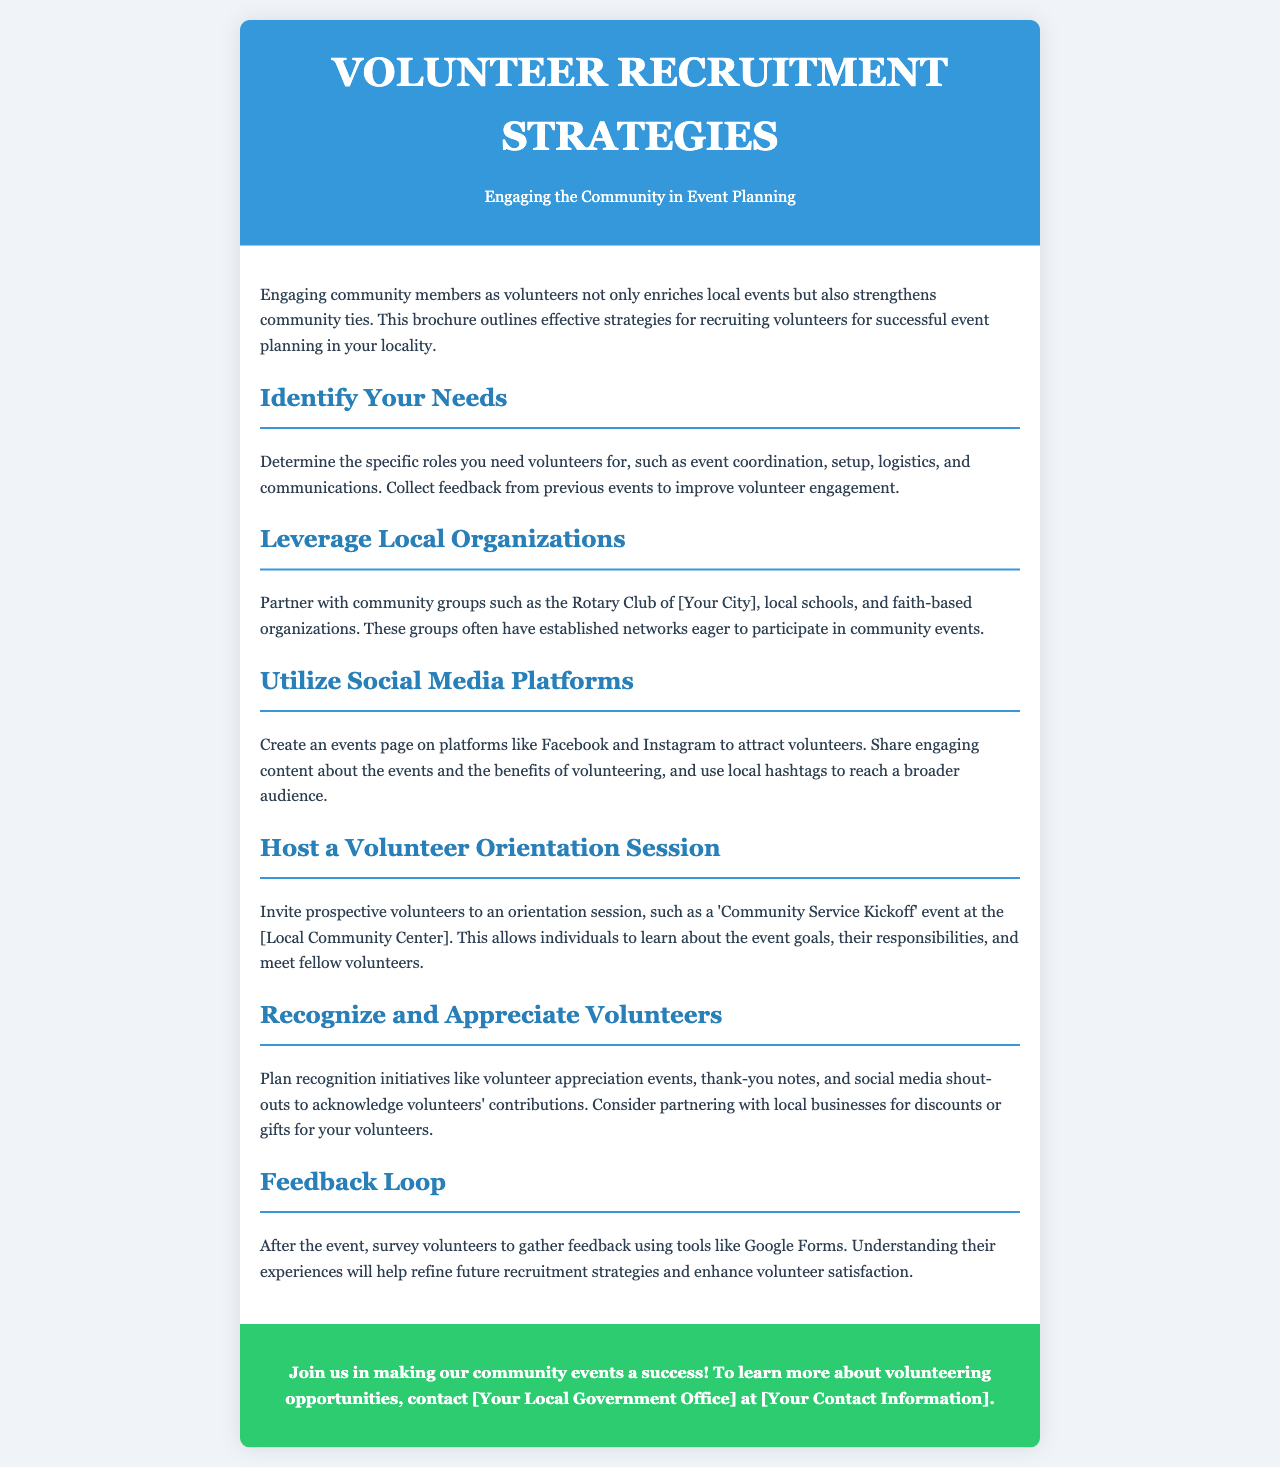What is the purpose of the brochure? The brochure outlines effective strategies for recruiting volunteers for successful event planning in your locality.
Answer: Volunteer recruitment strategies What should be determined before recruiting volunteers? You should determine the specific roles you need volunteers for, such as event coordination, setup, logistics, and communications.
Answer: Specific roles Which local organization is suggested for partnerships? Partner with community groups such as the Rotary Club of [Your City], local schools, and faith-based organizations.
Answer: Rotary Club What social media platforms are recommended to attract volunteers? Create an events page on platforms like Facebook and Instagram to attract volunteers.
Answer: Facebook and Instagram What event is suggested for introducing prospective volunteers? Invite prospective volunteers to an orientation session, such as a 'Community Service Kickoff' event at the [Local Community Center].
Answer: Community Service Kickoff What should be planned to appreciate volunteers? Plan recognition initiatives like volunteer appreciation events, thank-you notes, and social media shout-outs.
Answer: Volunteer appreciation events What tool is suggested for gathering feedback post-event? Survey volunteers to gather feedback using tools like Google Forms.
Answer: Google Forms Who should be contacted for more volunteer opportunities? To learn more about volunteering opportunities, contact [Your Local Government Office] at [Your Contact Information].
Answer: Your Local Government Office 